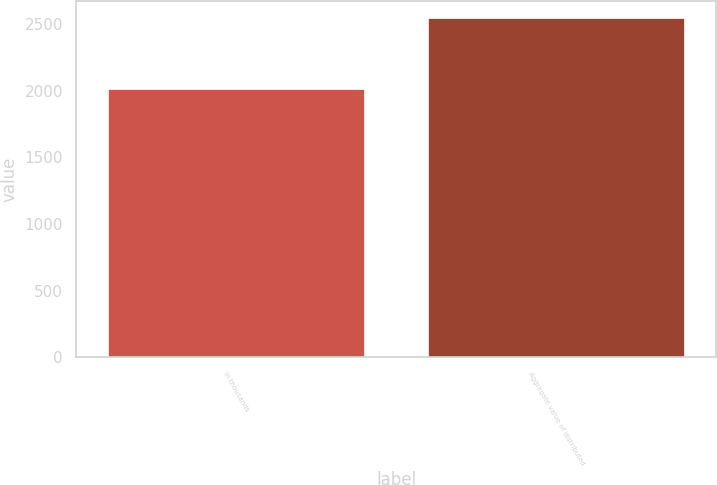<chart> <loc_0><loc_0><loc_500><loc_500><bar_chart><fcel>in thousands<fcel>Aggregate value of distributed<nl><fcel>2011<fcel>2548<nl></chart> 